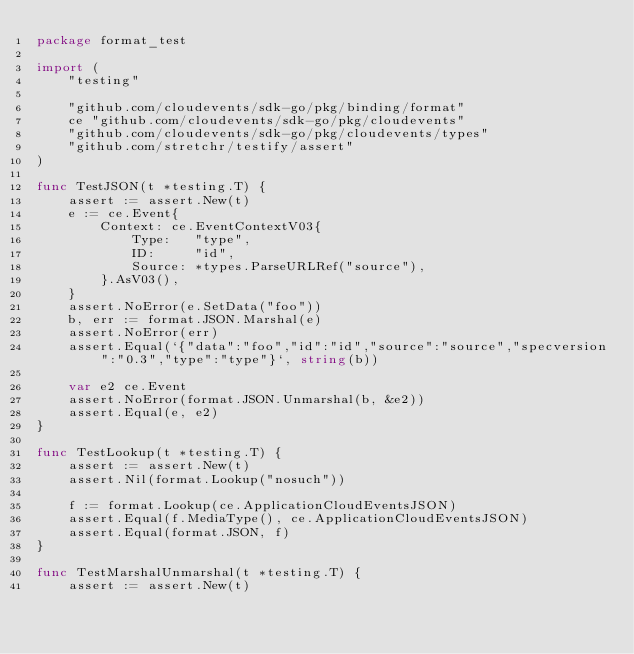Convert code to text. <code><loc_0><loc_0><loc_500><loc_500><_Go_>package format_test

import (
	"testing"

	"github.com/cloudevents/sdk-go/pkg/binding/format"
	ce "github.com/cloudevents/sdk-go/pkg/cloudevents"
	"github.com/cloudevents/sdk-go/pkg/cloudevents/types"
	"github.com/stretchr/testify/assert"
)

func TestJSON(t *testing.T) {
	assert := assert.New(t)
	e := ce.Event{
		Context: ce.EventContextV03{
			Type:   "type",
			ID:     "id",
			Source: *types.ParseURLRef("source"),
		}.AsV03(),
	}
	assert.NoError(e.SetData("foo"))
	b, err := format.JSON.Marshal(e)
	assert.NoError(err)
	assert.Equal(`{"data":"foo","id":"id","source":"source","specversion":"0.3","type":"type"}`, string(b))

	var e2 ce.Event
	assert.NoError(format.JSON.Unmarshal(b, &e2))
	assert.Equal(e, e2)
}

func TestLookup(t *testing.T) {
	assert := assert.New(t)
	assert.Nil(format.Lookup("nosuch"))

	f := format.Lookup(ce.ApplicationCloudEventsJSON)
	assert.Equal(f.MediaType(), ce.ApplicationCloudEventsJSON)
	assert.Equal(format.JSON, f)
}

func TestMarshalUnmarshal(t *testing.T) {
	assert := assert.New(t)</code> 